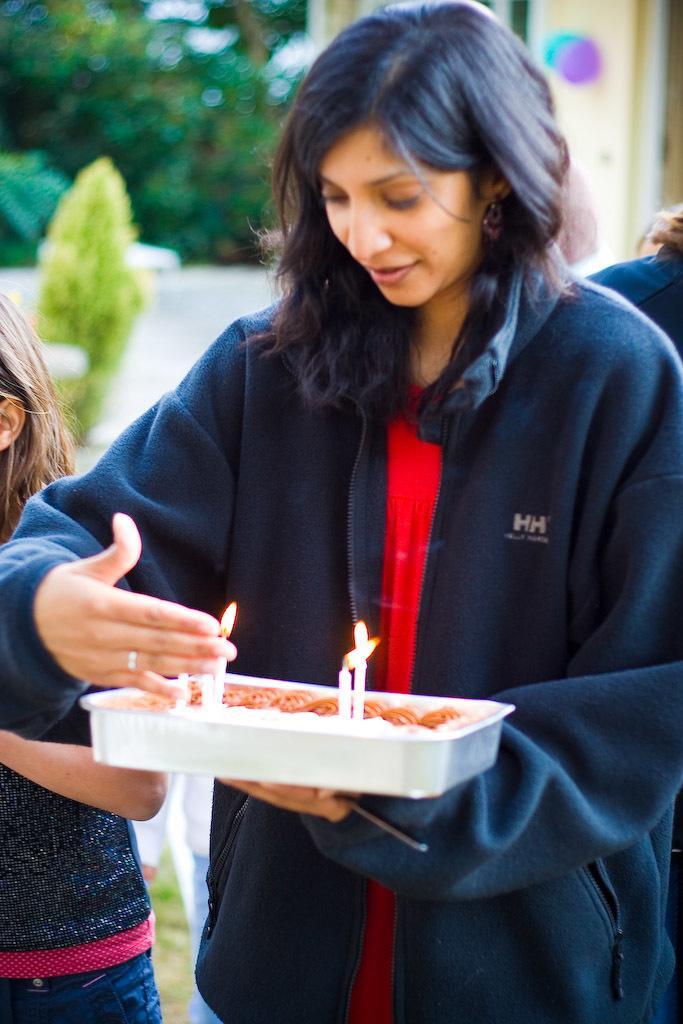How would you summarize this image in a sentence or two? There is a woman standing and holding container and we can see candles,behind this woman we can see persons. 